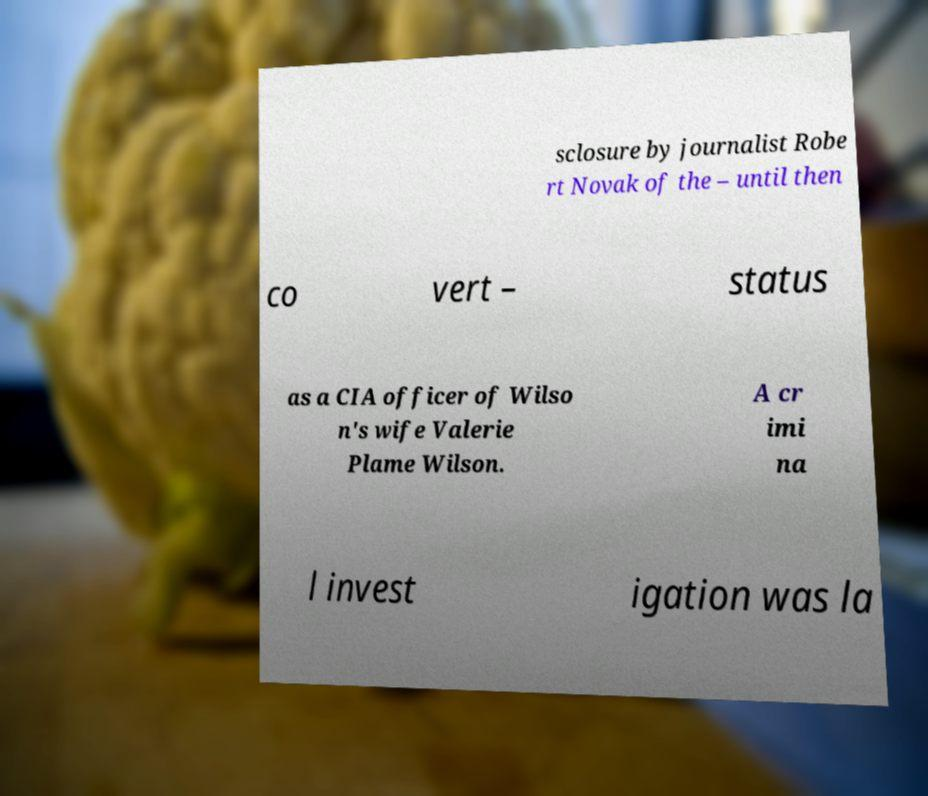Can you accurately transcribe the text from the provided image for me? sclosure by journalist Robe rt Novak of the – until then co vert – status as a CIA officer of Wilso n's wife Valerie Plame Wilson. A cr imi na l invest igation was la 